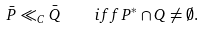<formula> <loc_0><loc_0><loc_500><loc_500>\bar { P } \ll _ { C } \bar { Q } \quad i f f P ^ { * } \cap Q \neq \emptyset .</formula> 